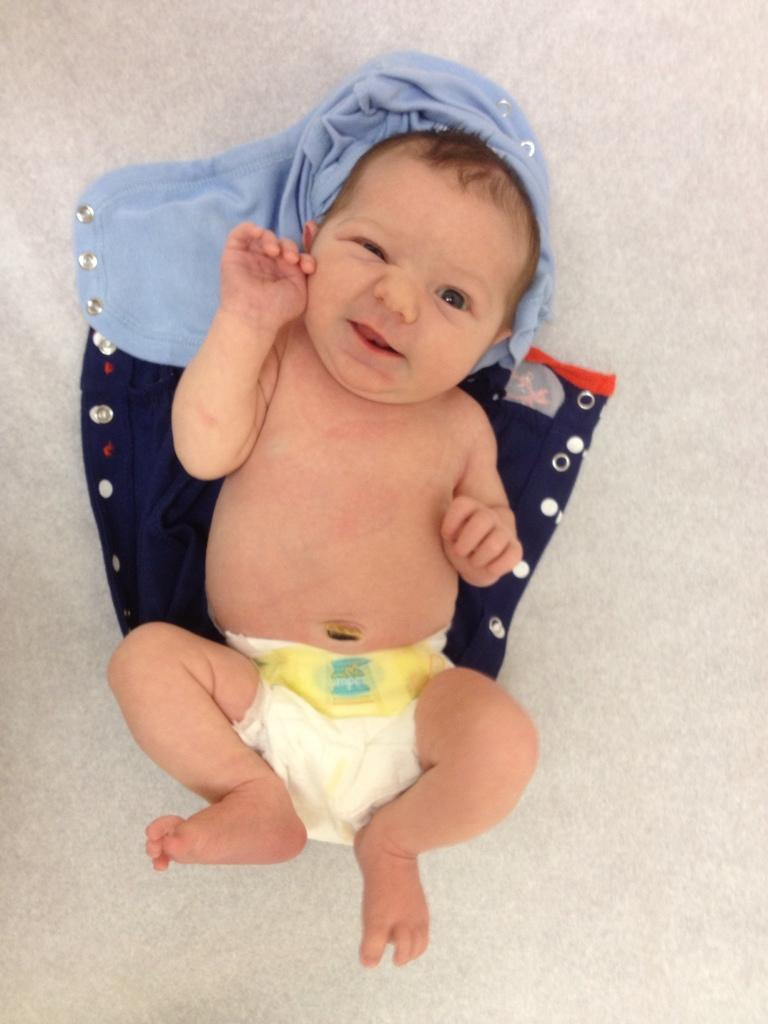What is the main subject of the image? There is a baby in the image. What is the baby lying on or near? There are two clothes under the baby. What type of education is the baby receiving in the image? There is no indication in the image that the baby is receiving any education. 